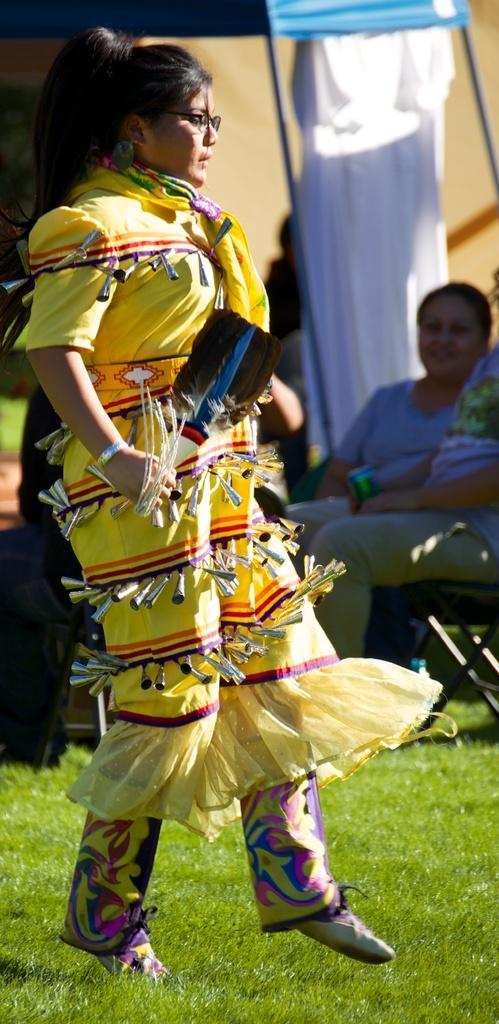Who is the main subject in the image? There is a woman in the image. What is the woman wearing? The woman is wearing a dress. What is the woman holding in her hand? The woman is holding a stick in her hand. Where is the woman standing? The woman is standing on the ground. What can be seen in the background of the image? There is a person sitting on a chair and a tent in the background. What type of owl can be seen perched on the woman's shoulder in the image? There is no owl present in the image; the woman is holding a stick in her hand. What sense does the woman appear to be using while holding the stick in the image? The image does not provide information about the woman's senses or her reason for holding the stick. 